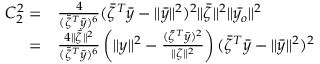<formula> <loc_0><loc_0><loc_500><loc_500>\begin{array} { r l } { C _ { 2 } ^ { 2 } = } & { \frac { 4 } { ( \bar { \zeta } ^ { T } \bar { y } ) ^ { 6 } } ( \bar { \zeta } ^ { T } \bar { y } - \| \bar { y } \| ^ { 2 } ) ^ { 2 } \| \bar { \zeta } \| ^ { 2 } \| \bar { y _ { o } } \| ^ { 2 } } \\ { = } & { \frac { 4 \| \bar { \zeta } \| ^ { 2 } } { ( \bar { \zeta } ^ { T } \bar { y } ) ^ { 6 } } \left ( \| y \| ^ { 2 } - \frac { ( \bar { \zeta } ^ { T } \bar { y } ) ^ { 2 } } { \| \zeta \| ^ { 2 } } \right ) ( \bar { \zeta } ^ { T } \bar { y } - \| \bar { y } \| ^ { 2 } ) ^ { 2 } } \end{array}</formula> 